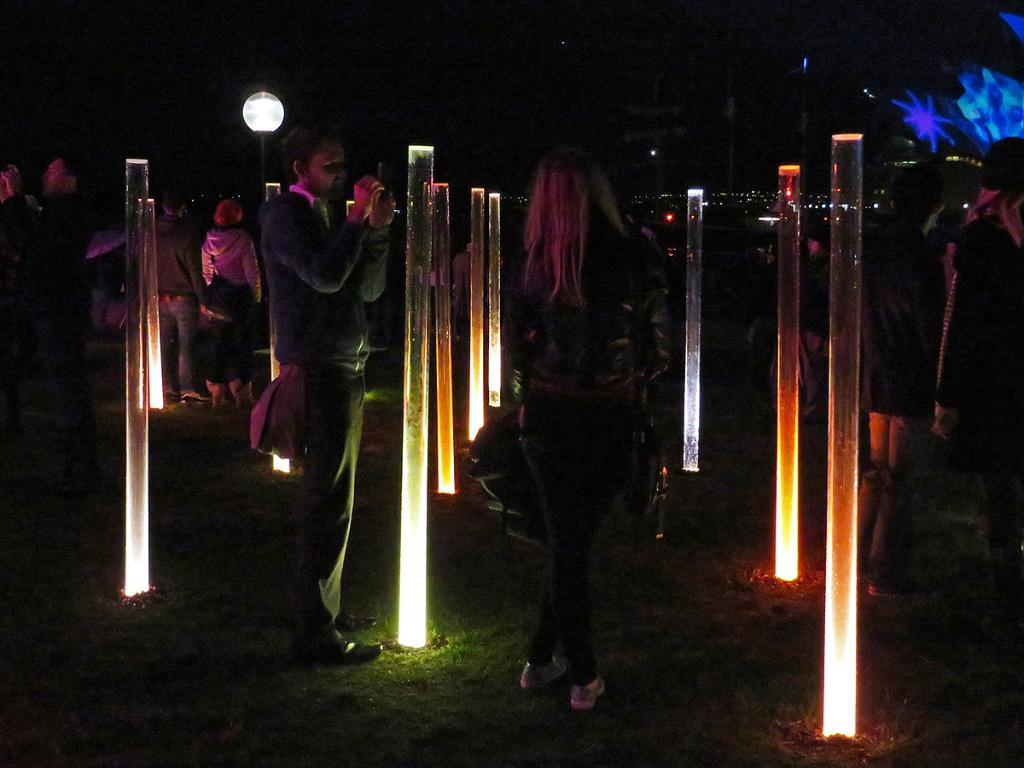What is happening in the image? There is a group of people standing in the image. What can be seen in the image besides the people? There are lights visible in the image. Can you describe the background of the image? The background of the image is blue and black. How many pets are visible in the image? There are no pets visible in the image. What type of fruit is being held by the people in the image? There is no fruit, such as a banana, visible in the image. 